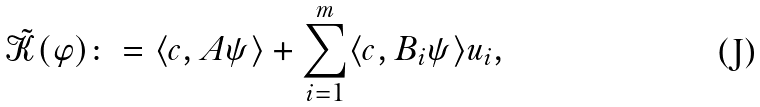<formula> <loc_0><loc_0><loc_500><loc_500>\tilde { \mathcal { K } } ( \varphi ) \colon = \langle c , A \psi \rangle + \sum _ { i = 1 } ^ { m } \langle c , B _ { i } \psi \rangle u _ { i } ,</formula> 